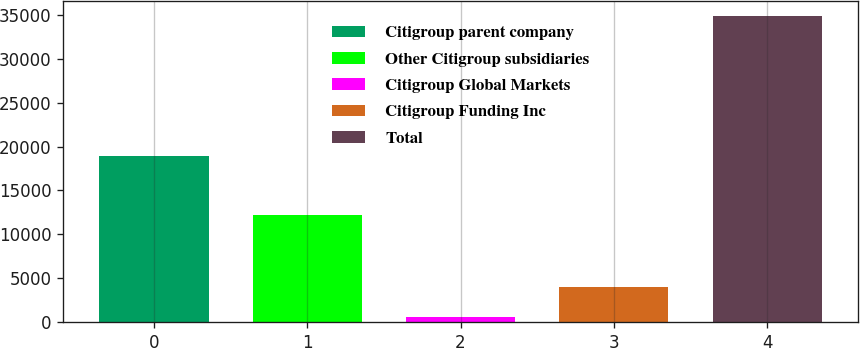<chart> <loc_0><loc_0><loc_500><loc_500><bar_chart><fcel>Citigroup parent company<fcel>Other Citigroup subsidiaries<fcel>Citigroup Global Markets<fcel>Citigroup Funding Inc<fcel>Total<nl><fcel>18916<fcel>12202<fcel>522<fcel>3959.3<fcel>34895<nl></chart> 